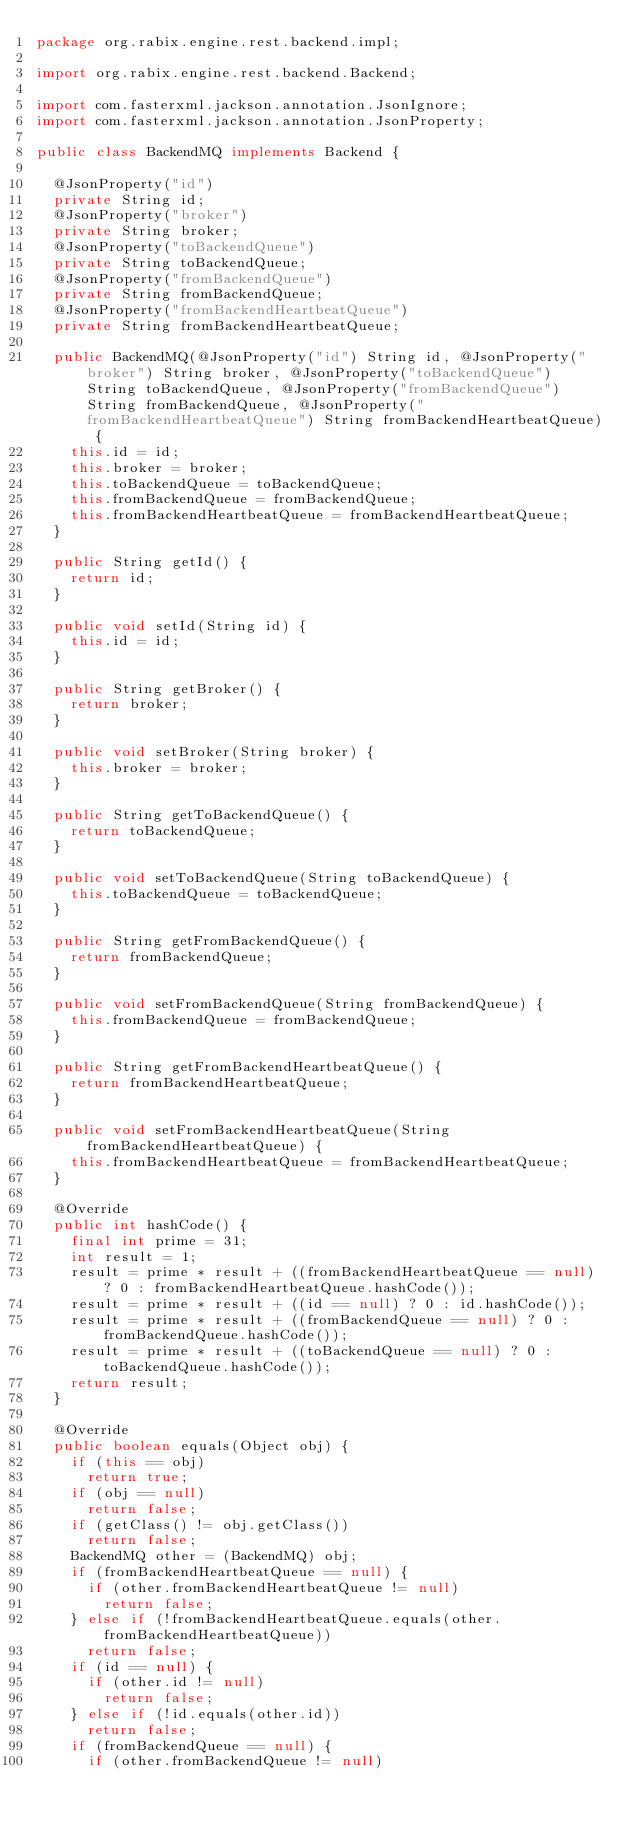<code> <loc_0><loc_0><loc_500><loc_500><_Java_>package org.rabix.engine.rest.backend.impl;

import org.rabix.engine.rest.backend.Backend;

import com.fasterxml.jackson.annotation.JsonIgnore;
import com.fasterxml.jackson.annotation.JsonProperty;

public class BackendMQ implements Backend {

  @JsonProperty("id")
  private String id;
  @JsonProperty("broker")
  private String broker;
  @JsonProperty("toBackendQueue")
  private String toBackendQueue;
  @JsonProperty("fromBackendQueue")
  private String fromBackendQueue;
  @JsonProperty("fromBackendHeartbeatQueue")
  private String fromBackendHeartbeatQueue;
  
  public BackendMQ(@JsonProperty("id") String id, @JsonProperty("broker") String broker, @JsonProperty("toBackendQueue") String toBackendQueue, @JsonProperty("fromBackendQueue") String fromBackendQueue, @JsonProperty("fromBackendHeartbeatQueue") String fromBackendHeartbeatQueue) {
    this.id = id;
    this.broker = broker;
    this.toBackendQueue = toBackendQueue;
    this.fromBackendQueue = fromBackendQueue;
    this.fromBackendHeartbeatQueue = fromBackendHeartbeatQueue;
  }

  public String getId() {
    return id;
  }

  public void setId(String id) {
    this.id = id;
  }

  public String getBroker() {
    return broker;
  }

  public void setBroker(String broker) {
    this.broker = broker;
  }

  public String getToBackendQueue() {
    return toBackendQueue;
  }

  public void setToBackendQueue(String toBackendQueue) {
    this.toBackendQueue = toBackendQueue;
  }

  public String getFromBackendQueue() {
    return fromBackendQueue;
  }

  public void setFromBackendQueue(String fromBackendQueue) {
    this.fromBackendQueue = fromBackendQueue;
  }

  public String getFromBackendHeartbeatQueue() {
    return fromBackendHeartbeatQueue;
  }

  public void setFromBackendHeartbeatQueue(String fromBackendHeartbeatQueue) {
    this.fromBackendHeartbeatQueue = fromBackendHeartbeatQueue;
  }

  @Override
  public int hashCode() {
    final int prime = 31;
    int result = 1;
    result = prime * result + ((fromBackendHeartbeatQueue == null) ? 0 : fromBackendHeartbeatQueue.hashCode());
    result = prime * result + ((id == null) ? 0 : id.hashCode());
    result = prime * result + ((fromBackendQueue == null) ? 0 : fromBackendQueue.hashCode());
    result = prime * result + ((toBackendQueue == null) ? 0 : toBackendQueue.hashCode());
    return result;
  }

  @Override
  public boolean equals(Object obj) {
    if (this == obj)
      return true;
    if (obj == null)
      return false;
    if (getClass() != obj.getClass())
      return false;
    BackendMQ other = (BackendMQ) obj;
    if (fromBackendHeartbeatQueue == null) {
      if (other.fromBackendHeartbeatQueue != null)
        return false;
    } else if (!fromBackendHeartbeatQueue.equals(other.fromBackendHeartbeatQueue))
      return false;
    if (id == null) {
      if (other.id != null)
        return false;
    } else if (!id.equals(other.id))
      return false;
    if (fromBackendQueue == null) {
      if (other.fromBackendQueue != null)</code> 